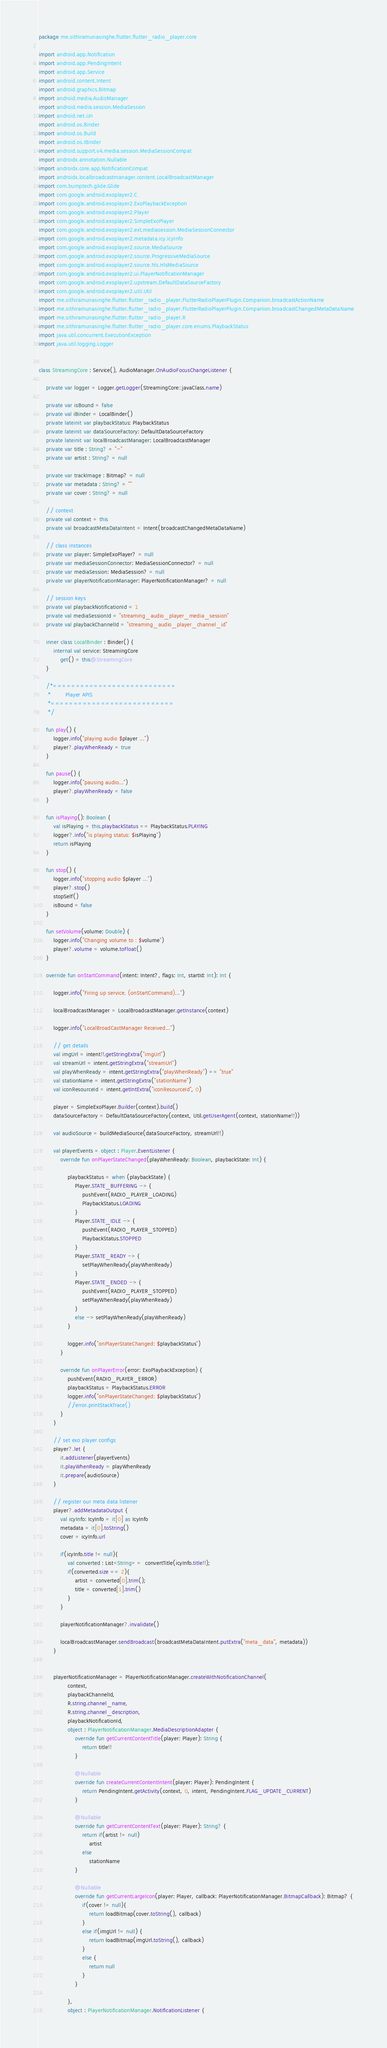<code> <loc_0><loc_0><loc_500><loc_500><_Kotlin_>package me.sithiramunasinghe.flutter.flutter_radio_player.core

import android.app.Notification
import android.app.PendingIntent
import android.app.Service
import android.content.Intent
import android.graphics.Bitmap
import android.media.AudioManager
import android.media.session.MediaSession
import android.net.Uri
import android.os.Binder
import android.os.Build
import android.os.IBinder
import android.support.v4.media.session.MediaSessionCompat
import androidx.annotation.Nullable
import androidx.core.app.NotificationCompat
import androidx.localbroadcastmanager.content.LocalBroadcastManager
import com.bumptech.glide.Glide
import com.google.android.exoplayer2.C
import com.google.android.exoplayer2.ExoPlaybackException
import com.google.android.exoplayer2.Player
import com.google.android.exoplayer2.SimpleExoPlayer
import com.google.android.exoplayer2.ext.mediasession.MediaSessionConnector
import com.google.android.exoplayer2.metadata.icy.IcyInfo
import com.google.android.exoplayer2.source.MediaSource
import com.google.android.exoplayer2.source.ProgressiveMediaSource
import com.google.android.exoplayer2.source.hls.HlsMediaSource
import com.google.android.exoplayer2.ui.PlayerNotificationManager
import com.google.android.exoplayer2.upstream.DefaultDataSourceFactory
import com.google.android.exoplayer2.util.Util
import me.sithiramunasinghe.flutter.flutter_radio_player.FlutterRadioPlayerPlugin.Companion.broadcastActionName
import me.sithiramunasinghe.flutter.flutter_radio_player.FlutterRadioPlayerPlugin.Companion.broadcastChangedMetaDataName
import me.sithiramunasinghe.flutter.flutter_radio_player.R
import me.sithiramunasinghe.flutter.flutter_radio_player.core.enums.PlaybackStatus
import java.util.concurrent.ExecutionException
import java.util.logging.Logger


class StreamingCore : Service(), AudioManager.OnAudioFocusChangeListener {

    private var logger = Logger.getLogger(StreamingCore::javaClass.name)

    private var isBound = false
    private val iBinder = LocalBinder()
    private lateinit var playbackStatus: PlaybackStatus
    private lateinit var dataSourceFactory: DefaultDataSourceFactory
    private lateinit var localBroadcastManager: LocalBroadcastManager
    private var title : String? = "-"
    private var artist : String? = null

    private var trackImage : Bitmap? = null
    private var metadata : String? = ""
    private var cover : String? = null

    // context
    private val context = this
    private val broadcastMetaDataIntent = Intent(broadcastChangedMetaDataName)

    // class instances
    private var player: SimpleExoPlayer? = null
    private var mediaSessionConnector: MediaSessionConnector? = null
    private var mediaSession: MediaSession? = null
    private var playerNotificationManager: PlayerNotificationManager? = null

    // session keys
    private val playbackNotificationId = 1
    private val mediaSessionId = "streaming_audio_player_media_session"
    private val playbackChannelId = "streaming_audio_player_channel_id"

    inner class LocalBinder : Binder() {
        internal val service: StreamingCore
            get() = this@StreamingCore
    }

    /*===========================
     *        Player APIS
     *===========================
     */

    fun play() {
        logger.info("playing audio $player ...")
        player?.playWhenReady = true
    }

    fun pause() {
        logger.info("pausing audio...")
        player?.playWhenReady = false
    }

    fun isPlaying(): Boolean {
        val isPlaying = this.playbackStatus == PlaybackStatus.PLAYING
        logger?.info("is playing status: $isPlaying")
        return isPlaying
    }

    fun stop() {
        logger.info("stopping audio $player ...")
        player?.stop()
        stopSelf()
        isBound = false
    }

    fun setVolume(volume: Double) {
        logger.info("Changing volume to : $volume")
        player?.volume = volume.toFloat()
    }

    override fun onStartCommand(intent: Intent?, flags: Int, startId: Int): Int {

        logger.info("Firing up service. (onStartCommand)...")

        localBroadcastManager = LocalBroadcastManager.getInstance(context)

        logger.info("LocalBroadCastManager Received...")

        // get details
        val imgUrl = intent!!.getStringExtra("imgUrl")
        val streamUrl = intent.getStringExtra("streamUrl")
        val playWhenReady = intent.getStringExtra("playWhenReady") == "true"
        val stationName = intent.getStringExtra("stationName")
        val iconResourceId = intent.getIntExtra("iconResourceId", 0)

        player = SimpleExoPlayer.Builder(context).build()
        dataSourceFactory = DefaultDataSourceFactory(context, Util.getUserAgent(context, stationName!!))

        val audioSource = buildMediaSource(dataSourceFactory, streamUrl!!)

        val playerEvents = object : Player.EventListener {
            override fun onPlayerStateChanged(playWhenReady: Boolean, playbackState: Int) {

                playbackStatus = when (playbackState) {
                    Player.STATE_BUFFERING -> {
                        pushEvent(RADIO_PLAYER_LOADING)
                        PlaybackStatus.LOADING
                    }
                    Player.STATE_IDLE -> {
                        pushEvent(RADIO_PLAYER_STOPPED)
                        PlaybackStatus.STOPPED
                    }
                    Player.STATE_READY -> {
                        setPlayWhenReady(playWhenReady)
                    }
                    Player.STATE_ENDED -> {
                        pushEvent(RADIO_PLAYER_STOPPED)
                        setPlayWhenReady(playWhenReady)
                    }
                    else -> setPlayWhenReady(playWhenReady)
                }

                logger.info("onPlayerStateChanged: $playbackStatus")
            }

            override fun onPlayerError(error: ExoPlaybackException) {
                pushEvent(RADIO_PLAYER_ERROR)
                playbackStatus = PlaybackStatus.ERROR
                logger.info("onPlayerStateChanged: $playbackStatus")
                //error.printStackTrace()
            }
        }

        // set exo player configs
        player?.let {
            it.addListener(playerEvents)
            it.playWhenReady = playWhenReady
            it.prepare(audioSource)
        }

        // register our meta data listener
        player?.addMetadataOutput {
            val icyInfo: IcyInfo = it[0] as IcyInfo
            metadata = it[0].toString()
            cover = icyInfo.url

            if(icyInfo.title != null){
                val converted : List<String> =  convertTitle(icyInfo.title!!);
                if(converted.size == 2){
                    artist = converted[0].trim();
                    title = converted[1].trim()
                }
            }

            playerNotificationManager?.invalidate()

            localBroadcastManager.sendBroadcast(broadcastMetaDataIntent.putExtra("meta_data", metadata))
        }


        playerNotificationManager = PlayerNotificationManager.createWithNotificationChannel(
                context,
                playbackChannelId,
                R.string.channel_name,
                R.string.channel_description,
                playbackNotificationId,
                object : PlayerNotificationManager.MediaDescriptionAdapter {
                    override fun getCurrentContentTitle(player: Player): String {
                        return title!!
                    }

                    @Nullable
                    override fun createCurrentContentIntent(player: Player): PendingIntent {
                        return PendingIntent.getActivity(context, 0, intent, PendingIntent.FLAG_UPDATE_CURRENT)
                    }

                    @Nullable
                    override fun getCurrentContentText(player: Player): String? {
                        return if(artist != null)
                            artist
                        else
                            stationName
                    }

                    @Nullable
                    override fun getCurrentLargeIcon(player: Player, callback: PlayerNotificationManager.BitmapCallback): Bitmap? {
                        if(cover != null){
                            return loadBitmap(cover.toString(), callback)
                        }
                        else if(imgUrl != null) {
                            return loadBitmap(imgUrl.toString(), callback)
                        }
                        else {
                            return null
                        }
                    }

                },
                object : PlayerNotificationManager.NotificationListener {</code> 